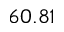<formula> <loc_0><loc_0><loc_500><loc_500>6 0 . 8 1</formula> 